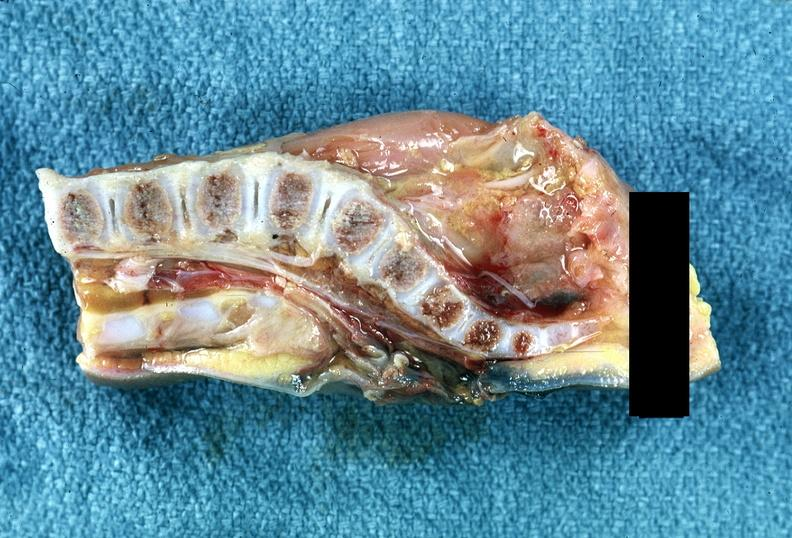what does this image show?
Answer the question using a single word or phrase. Neural tube defect 